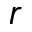Convert formula to latex. <formula><loc_0><loc_0><loc_500><loc_500>r</formula> 